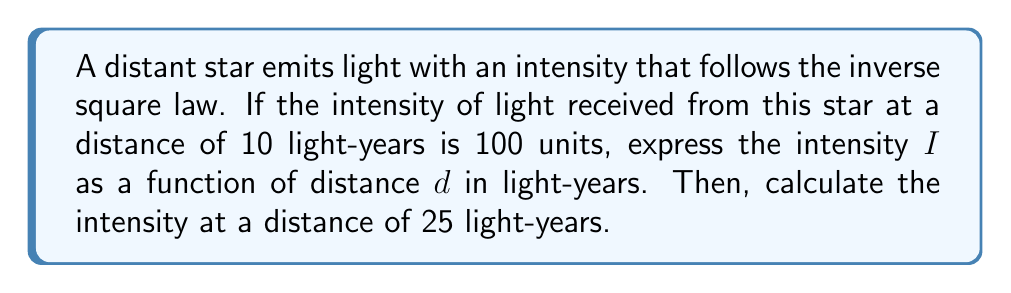Solve this math problem. 1) The inverse square law states that the intensity of light is inversely proportional to the square of the distance from the source. We can express this as:

   $$ I \propto \frac{1}{d^2} $$

2) To turn this into an equation, we introduce a constant $k$:

   $$ I = \frac{k}{d^2} $$

3) We can find $k$ using the given information: when $d = 10$ light-years, $I = 100$ units.

   $$ 100 = \frac{k}{10^2} $$

4) Solving for $k$:

   $$ k = 100 \cdot 10^2 = 10,000 $$

5) Therefore, our function for intensity is:

   $$ I(d) = \frac{10,000}{d^2} $$

6) To find the intensity at 25 light-years:

   $$ I(25) = \frac{10,000}{25^2} = \frac{10,000}{625} = 16 $$

Thus, the intensity at 25 light-years is 16 units.
Answer: $I(d) = \frac{10,000}{d^2}$; 16 units 